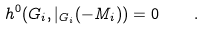Convert formula to latex. <formula><loc_0><loc_0><loc_500><loc_500>h ^ { 0 } ( G _ { i } , \L | _ { G _ { i } } ( - M _ { i } ) ) = 0 \quad .</formula> 